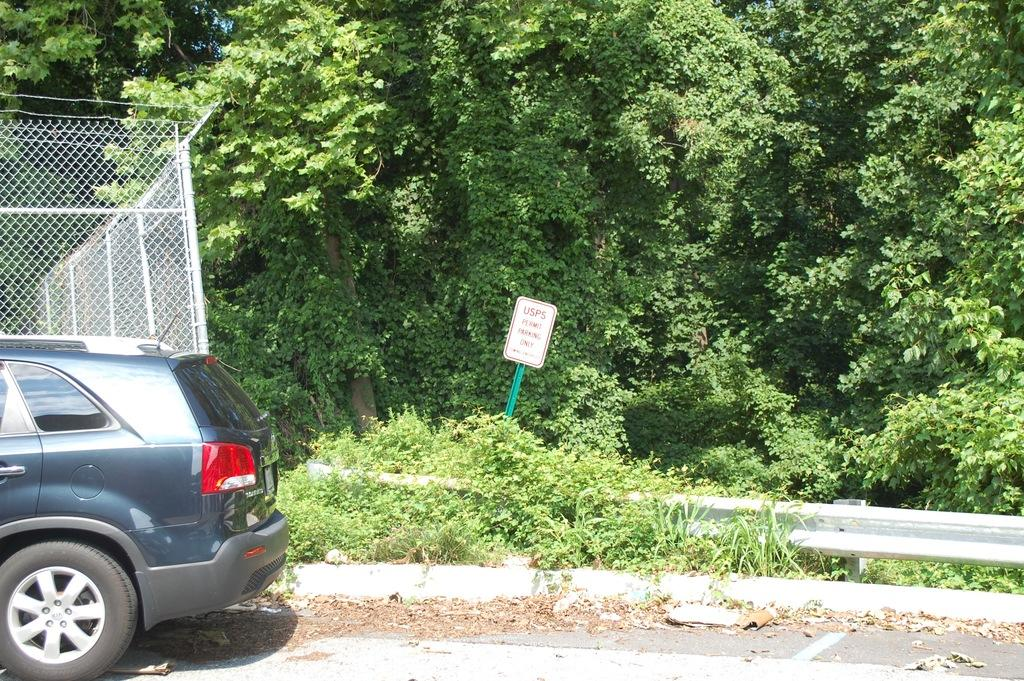What type of natural elements can be seen in the image? There are trees in the image. What man-made object is present in the image? There is a board in the image. What mode of transportation can be seen in the image? There is a vehicle on the road in the image. What type of barrier is located beside the vehicle in the image? There is a fence beside the vehicle in the image. What type of cable can be seen running through the trees in the image? There is no cable visible in the image; only trees, a board, a vehicle, and a fence are present. 